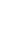<code> <loc_0><loc_0><loc_500><loc_500><_SQL_>
</code> 